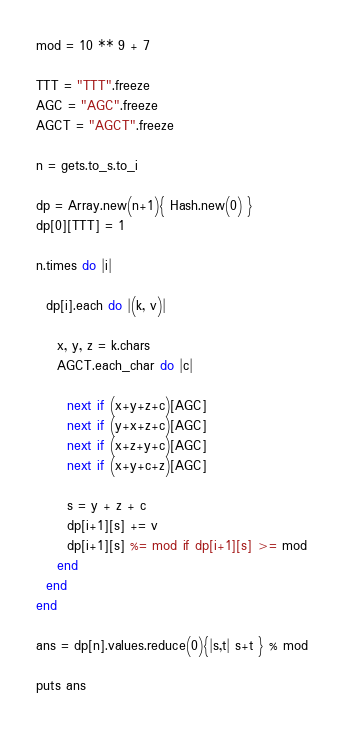Convert code to text. <code><loc_0><loc_0><loc_500><loc_500><_Ruby_>mod = 10 ** 9 + 7

TTT = "TTT".freeze
AGC = "AGC".freeze
AGCT = "AGCT".freeze

n = gets.to_s.to_i

dp = Array.new(n+1){ Hash.new(0) }
dp[0][TTT] = 1

n.times do |i|
  
  dp[i].each do |(k, v)|
    
    x, y, z = k.chars
    AGCT.each_char do |c|
      
      next if (x+y+z+c)[AGC]
      next if (y+x+z+c)[AGC]
      next if (x+z+y+c)[AGC]
      next if (x+y+c+z)[AGC]
      
      s = y + z + c
      dp[i+1][s] += v
      dp[i+1][s] %= mod if dp[i+1][s] >= mod
    end
  end
end

ans = dp[n].values.reduce(0){|s,t| s+t } % mod

puts ans</code> 